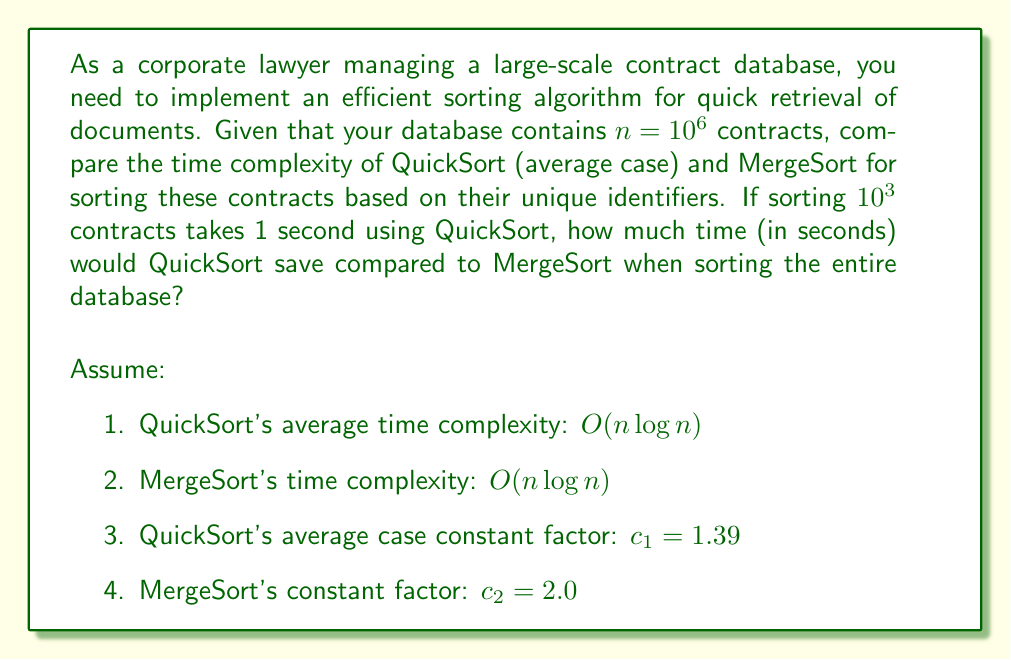Can you answer this question? Let's approach this step-by-step:

1) First, we need to establish the time complexities:
   QuickSort (average case): $T_q(n) = c_1 n \log n$
   MergeSort: $T_m(n) = c_2 n \log n$

2) We're given that QuickSort takes 1 second for $10^3$ contracts. Let's use this to find $c_1$:
   $1 = c_1 \cdot 10^3 \log 10^3$
   $1 = c_1 \cdot 10^3 \cdot 3 \log 10$
   $c_1 = \frac{1}{3000 \log 10} \approx 1.39 \times 10^{-4}$

3) Now, let's calculate the time for sorting $10^6$ contracts using QuickSort:
   $T_q(10^6) = 1.39 \times 10^{-4} \cdot 10^6 \log 10^6$
              $= 139 \cdot 6 \log 10$
              $\approx 1918.56$ seconds

4) For MergeSort:
   $T_m(10^6) = 2.0 \times 10^{-4} \cdot 10^6 \log 10^6$
              $= 200 \cdot 6 \log 10$
              $\approx 2760.23$ seconds

5) Time saved by using QuickSort:
   $T_m(10^6) - T_q(10^6) = 2760.23 - 1918.56 = 841.67$ seconds
Answer: 841.67 seconds 